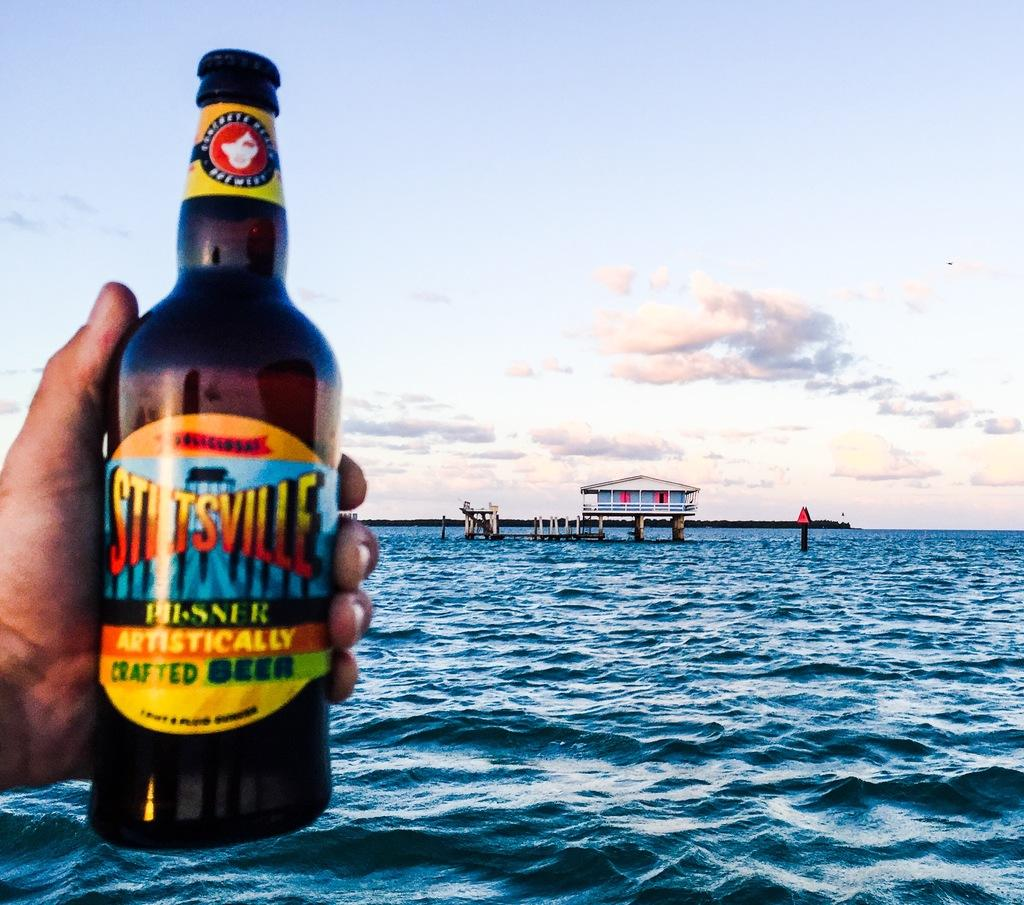<image>
Write a terse but informative summary of the picture. A bottle of Stiltville is held up against the backdrop of the ocean. 